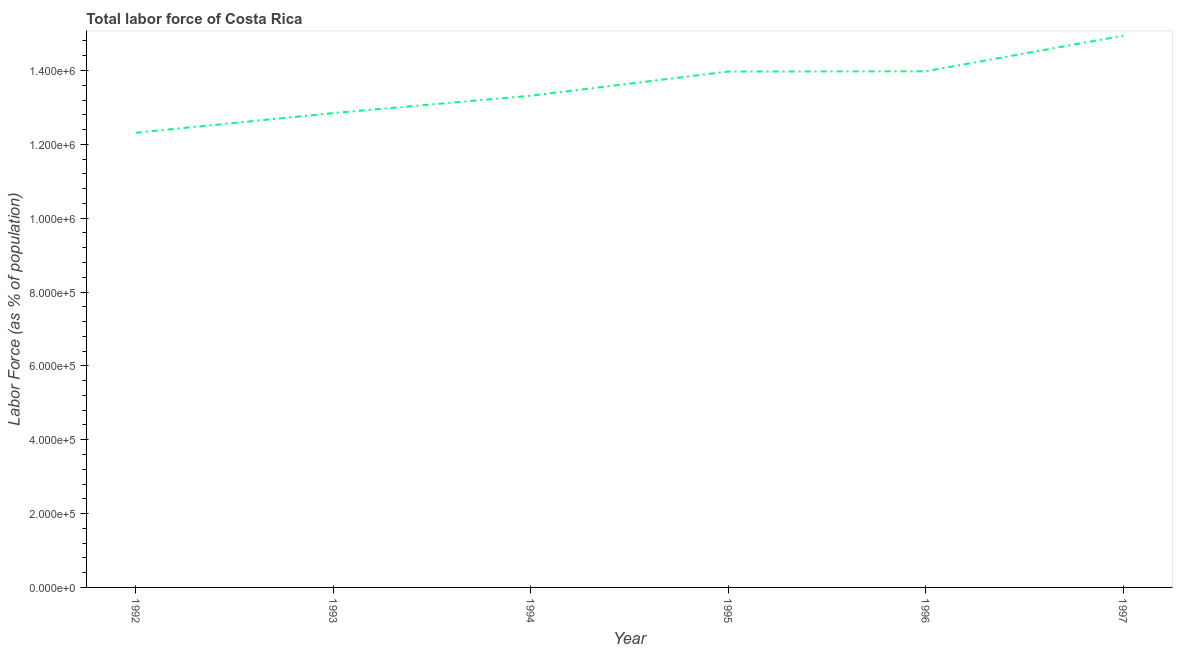What is the total labor force in 1993?
Provide a succinct answer. 1.28e+06. Across all years, what is the maximum total labor force?
Your answer should be compact. 1.49e+06. Across all years, what is the minimum total labor force?
Offer a very short reply. 1.23e+06. In which year was the total labor force maximum?
Offer a terse response. 1997. What is the sum of the total labor force?
Offer a very short reply. 8.14e+06. What is the difference between the total labor force in 1994 and 1997?
Your answer should be very brief. -1.63e+05. What is the average total labor force per year?
Keep it short and to the point. 1.36e+06. What is the median total labor force?
Make the answer very short. 1.36e+06. Do a majority of the years between 1993 and 1997 (inclusive) have total labor force greater than 240000 %?
Your response must be concise. Yes. What is the ratio of the total labor force in 1994 to that in 1995?
Provide a short and direct response. 0.95. What is the difference between the highest and the second highest total labor force?
Make the answer very short. 9.64e+04. What is the difference between the highest and the lowest total labor force?
Your response must be concise. 2.63e+05. In how many years, is the total labor force greater than the average total labor force taken over all years?
Provide a short and direct response. 3. How many lines are there?
Your answer should be very brief. 1. What is the difference between two consecutive major ticks on the Y-axis?
Provide a short and direct response. 2.00e+05. Does the graph contain any zero values?
Provide a short and direct response. No. Does the graph contain grids?
Your answer should be compact. No. What is the title of the graph?
Ensure brevity in your answer.  Total labor force of Costa Rica. What is the label or title of the X-axis?
Provide a succinct answer. Year. What is the label or title of the Y-axis?
Give a very brief answer. Labor Force (as % of population). What is the Labor Force (as % of population) in 1992?
Your answer should be very brief. 1.23e+06. What is the Labor Force (as % of population) in 1993?
Ensure brevity in your answer.  1.28e+06. What is the Labor Force (as % of population) in 1994?
Provide a short and direct response. 1.33e+06. What is the Labor Force (as % of population) of 1995?
Ensure brevity in your answer.  1.40e+06. What is the Labor Force (as % of population) in 1996?
Ensure brevity in your answer.  1.40e+06. What is the Labor Force (as % of population) in 1997?
Your response must be concise. 1.49e+06. What is the difference between the Labor Force (as % of population) in 1992 and 1993?
Your answer should be very brief. -5.32e+04. What is the difference between the Labor Force (as % of population) in 1992 and 1994?
Your answer should be compact. -1.00e+05. What is the difference between the Labor Force (as % of population) in 1992 and 1995?
Keep it short and to the point. -1.66e+05. What is the difference between the Labor Force (as % of population) in 1992 and 1996?
Make the answer very short. -1.66e+05. What is the difference between the Labor Force (as % of population) in 1992 and 1997?
Make the answer very short. -2.63e+05. What is the difference between the Labor Force (as % of population) in 1993 and 1994?
Keep it short and to the point. -4.71e+04. What is the difference between the Labor Force (as % of population) in 1993 and 1995?
Your answer should be compact. -1.13e+05. What is the difference between the Labor Force (as % of population) in 1993 and 1996?
Give a very brief answer. -1.13e+05. What is the difference between the Labor Force (as % of population) in 1993 and 1997?
Provide a succinct answer. -2.10e+05. What is the difference between the Labor Force (as % of population) in 1994 and 1995?
Your answer should be very brief. -6.55e+04. What is the difference between the Labor Force (as % of population) in 1994 and 1996?
Provide a succinct answer. -6.62e+04. What is the difference between the Labor Force (as % of population) in 1994 and 1997?
Your answer should be compact. -1.63e+05. What is the difference between the Labor Force (as % of population) in 1995 and 1996?
Your answer should be very brief. -719. What is the difference between the Labor Force (as % of population) in 1995 and 1997?
Provide a short and direct response. -9.72e+04. What is the difference between the Labor Force (as % of population) in 1996 and 1997?
Ensure brevity in your answer.  -9.64e+04. What is the ratio of the Labor Force (as % of population) in 1992 to that in 1994?
Provide a succinct answer. 0.93. What is the ratio of the Labor Force (as % of population) in 1992 to that in 1995?
Give a very brief answer. 0.88. What is the ratio of the Labor Force (as % of population) in 1992 to that in 1996?
Provide a succinct answer. 0.88. What is the ratio of the Labor Force (as % of population) in 1992 to that in 1997?
Give a very brief answer. 0.82. What is the ratio of the Labor Force (as % of population) in 1993 to that in 1994?
Offer a very short reply. 0.96. What is the ratio of the Labor Force (as % of population) in 1993 to that in 1995?
Provide a succinct answer. 0.92. What is the ratio of the Labor Force (as % of population) in 1993 to that in 1996?
Keep it short and to the point. 0.92. What is the ratio of the Labor Force (as % of population) in 1993 to that in 1997?
Your answer should be compact. 0.86. What is the ratio of the Labor Force (as % of population) in 1994 to that in 1995?
Ensure brevity in your answer.  0.95. What is the ratio of the Labor Force (as % of population) in 1994 to that in 1996?
Offer a very short reply. 0.95. What is the ratio of the Labor Force (as % of population) in 1994 to that in 1997?
Give a very brief answer. 0.89. What is the ratio of the Labor Force (as % of population) in 1995 to that in 1997?
Offer a terse response. 0.94. What is the ratio of the Labor Force (as % of population) in 1996 to that in 1997?
Provide a short and direct response. 0.94. 